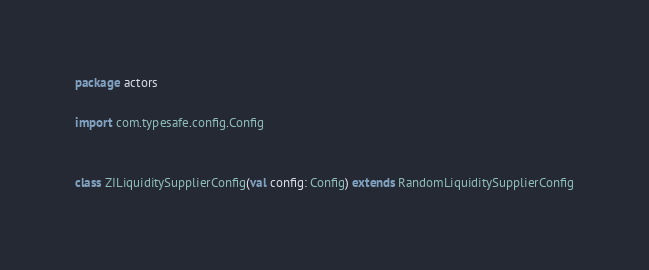<code> <loc_0><loc_0><loc_500><loc_500><_Scala_>package actors

import com.typesafe.config.Config


class ZILiquiditySupplierConfig(val config: Config) extends RandomLiquiditySupplierConfig
</code> 